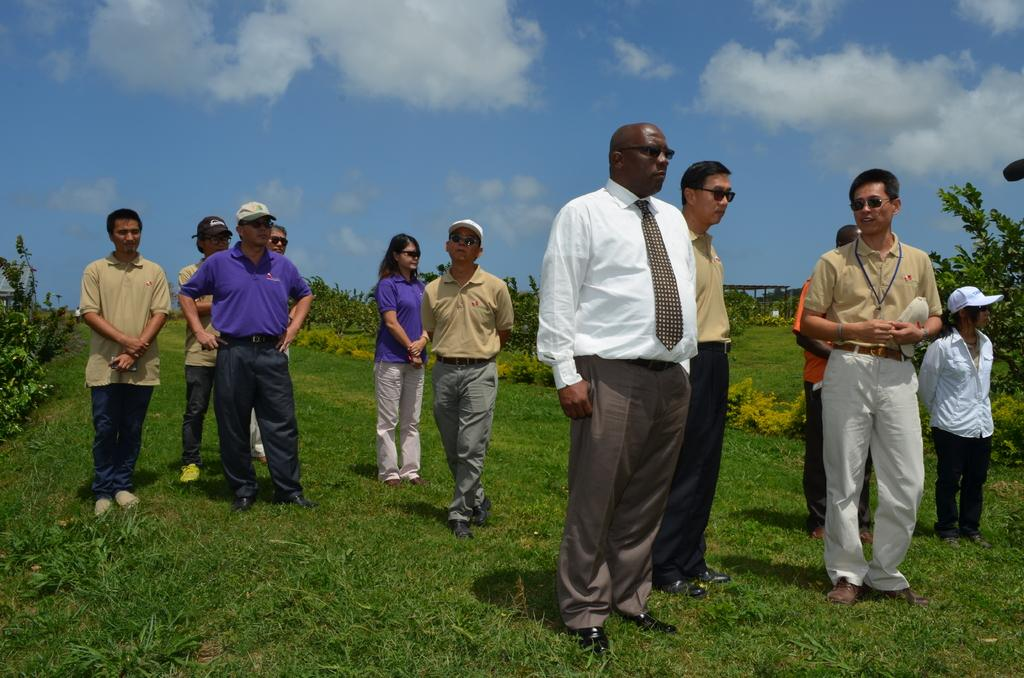How many people are in the group in the image? There is a group of people in the image, but the exact number is not specified. What is the surface the people are standing on? The people are standing on the grass in the image. What type of headwear can be seen on some people in the group? Some people in the group are wearing caps. What can be seen in the background of the image besides the sky? There are plants and sheds visible in the background of the image. What is the condition of the sky in the image? The sky is visible in the background of the image, and there are clouds visible. What type of mint is being used to create friction between the people in the image? There is no mention of mint or friction between the people in the image. The people are simply standing on the grass. 